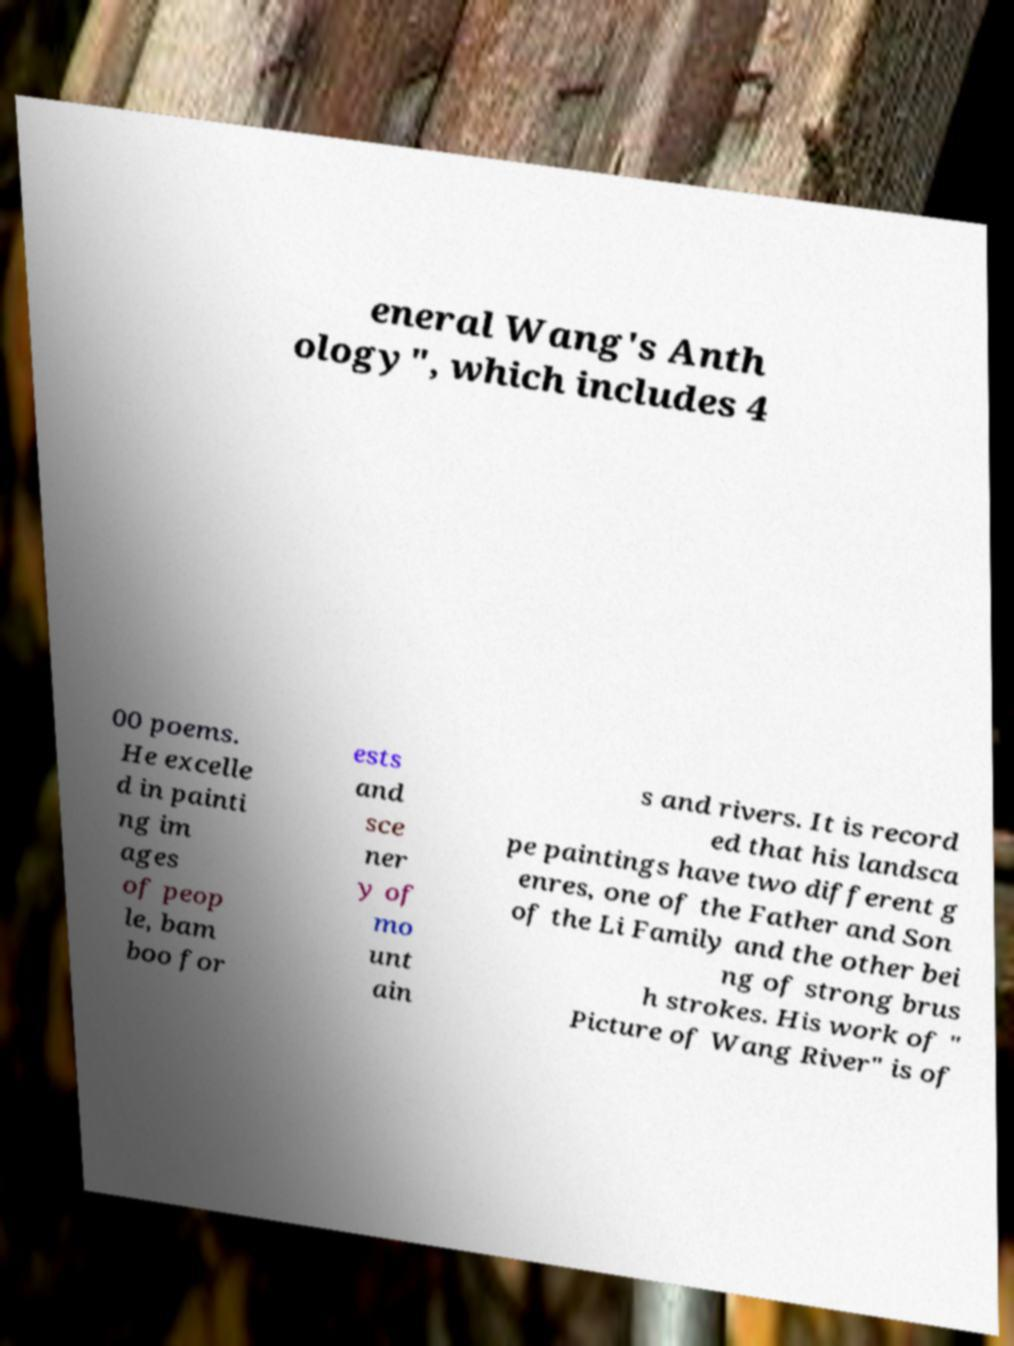There's text embedded in this image that I need extracted. Can you transcribe it verbatim? eneral Wang's Anth ology", which includes 4 00 poems. He excelle d in painti ng im ages of peop le, bam boo for ests and sce ner y of mo unt ain s and rivers. It is record ed that his landsca pe paintings have two different g enres, one of the Father and Son of the Li Family and the other bei ng of strong brus h strokes. His work of " Picture of Wang River" is of 